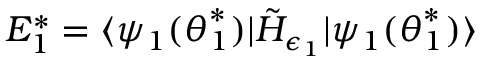Convert formula to latex. <formula><loc_0><loc_0><loc_500><loc_500>E _ { 1 } ^ { * } = \langle \psi _ { 1 } ( \theta _ { 1 } ^ { * } ) | \tilde { H } _ { \epsilon _ { 1 } } | \psi _ { 1 } ( \theta _ { 1 } ^ { * } ) \rangle</formula> 